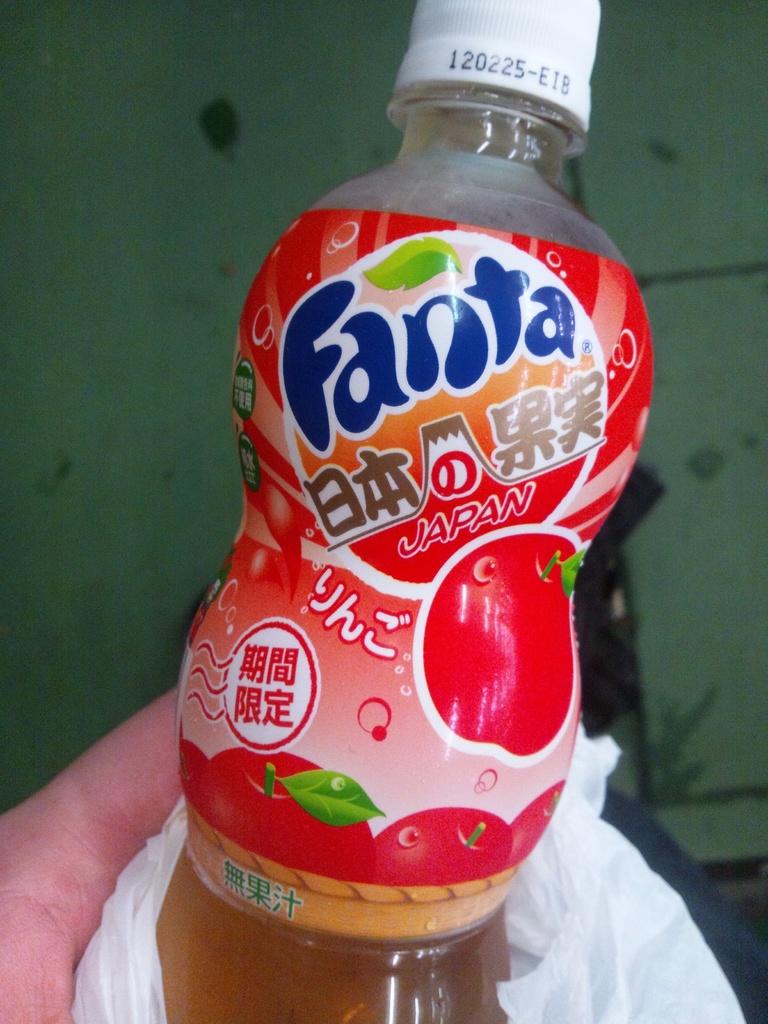What country did this drink come from?
Offer a very short reply. Japan. 